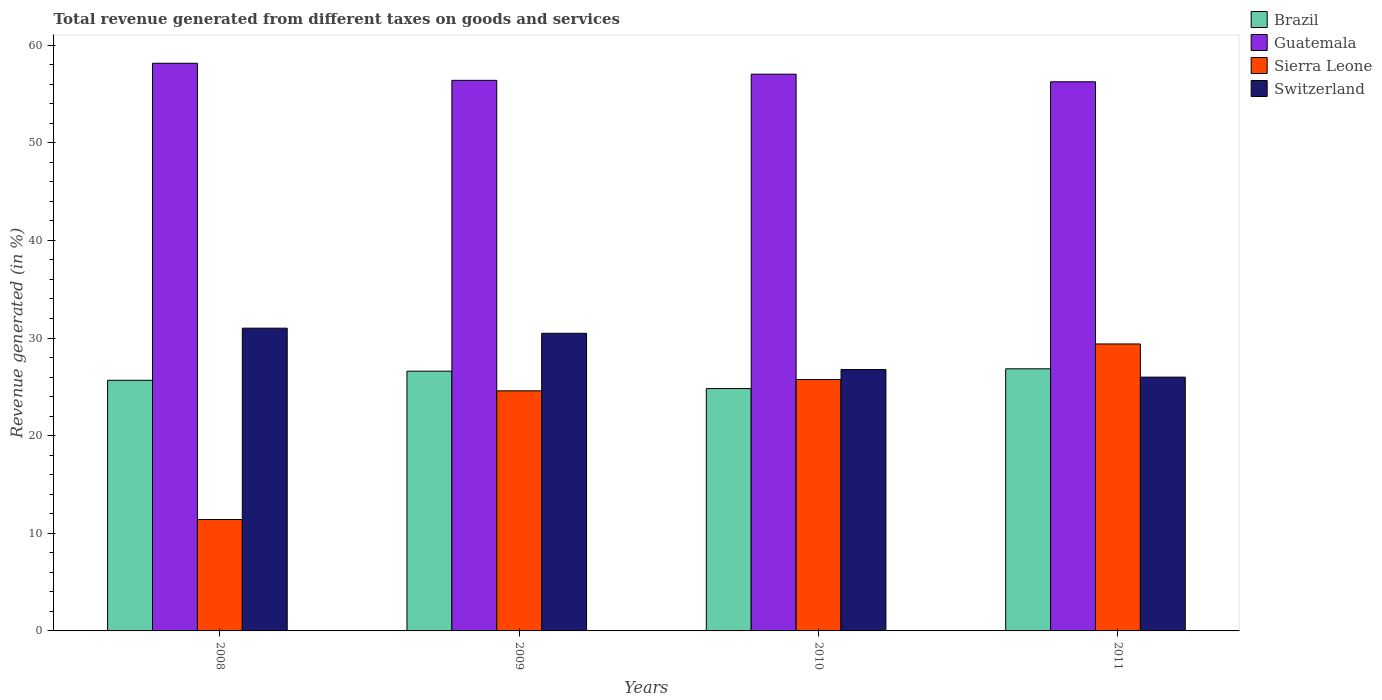How many groups of bars are there?
Your answer should be very brief. 4. Are the number of bars per tick equal to the number of legend labels?
Ensure brevity in your answer.  Yes. Are the number of bars on each tick of the X-axis equal?
Your answer should be very brief. Yes. How many bars are there on the 1st tick from the left?
Give a very brief answer. 4. How many bars are there on the 2nd tick from the right?
Make the answer very short. 4. What is the total revenue generated in Switzerland in 2010?
Provide a short and direct response. 26.77. Across all years, what is the maximum total revenue generated in Sierra Leone?
Keep it short and to the point. 29.39. Across all years, what is the minimum total revenue generated in Switzerland?
Your answer should be compact. 25.99. In which year was the total revenue generated in Brazil maximum?
Your answer should be compact. 2011. What is the total total revenue generated in Switzerland in the graph?
Provide a short and direct response. 114.25. What is the difference between the total revenue generated in Brazil in 2009 and that in 2010?
Offer a very short reply. 1.78. What is the difference between the total revenue generated in Switzerland in 2011 and the total revenue generated in Guatemala in 2010?
Your answer should be compact. -31.03. What is the average total revenue generated in Brazil per year?
Your response must be concise. 25.99. In the year 2008, what is the difference between the total revenue generated in Sierra Leone and total revenue generated in Switzerland?
Your answer should be very brief. -19.6. What is the ratio of the total revenue generated in Brazil in 2008 to that in 2010?
Your response must be concise. 1.03. Is the total revenue generated in Switzerland in 2008 less than that in 2009?
Provide a succinct answer. No. What is the difference between the highest and the second highest total revenue generated in Guatemala?
Provide a short and direct response. 1.12. What is the difference between the highest and the lowest total revenue generated in Sierra Leone?
Your answer should be very brief. 17.98. In how many years, is the total revenue generated in Sierra Leone greater than the average total revenue generated in Sierra Leone taken over all years?
Your response must be concise. 3. Is the sum of the total revenue generated in Sierra Leone in 2009 and 2011 greater than the maximum total revenue generated in Guatemala across all years?
Make the answer very short. No. Is it the case that in every year, the sum of the total revenue generated in Brazil and total revenue generated in Sierra Leone is greater than the sum of total revenue generated in Switzerland and total revenue generated in Guatemala?
Provide a short and direct response. No. What does the 3rd bar from the left in 2011 represents?
Provide a short and direct response. Sierra Leone. What does the 1st bar from the right in 2009 represents?
Offer a terse response. Switzerland. Are the values on the major ticks of Y-axis written in scientific E-notation?
Make the answer very short. No. How many legend labels are there?
Give a very brief answer. 4. What is the title of the graph?
Your response must be concise. Total revenue generated from different taxes on goods and services. What is the label or title of the Y-axis?
Your answer should be very brief. Revenue generated (in %). What is the Revenue generated (in %) of Brazil in 2008?
Offer a very short reply. 25.67. What is the Revenue generated (in %) in Guatemala in 2008?
Your answer should be compact. 58.14. What is the Revenue generated (in %) of Sierra Leone in 2008?
Provide a succinct answer. 11.41. What is the Revenue generated (in %) in Switzerland in 2008?
Provide a succinct answer. 31.01. What is the Revenue generated (in %) of Brazil in 2009?
Your answer should be compact. 26.61. What is the Revenue generated (in %) of Guatemala in 2009?
Offer a terse response. 56.39. What is the Revenue generated (in %) of Sierra Leone in 2009?
Your response must be concise. 24.59. What is the Revenue generated (in %) of Switzerland in 2009?
Your response must be concise. 30.48. What is the Revenue generated (in %) in Brazil in 2010?
Your answer should be compact. 24.82. What is the Revenue generated (in %) in Guatemala in 2010?
Give a very brief answer. 57.02. What is the Revenue generated (in %) of Sierra Leone in 2010?
Give a very brief answer. 25.75. What is the Revenue generated (in %) of Switzerland in 2010?
Provide a short and direct response. 26.77. What is the Revenue generated (in %) of Brazil in 2011?
Your answer should be very brief. 26.85. What is the Revenue generated (in %) of Guatemala in 2011?
Your answer should be compact. 56.25. What is the Revenue generated (in %) of Sierra Leone in 2011?
Ensure brevity in your answer.  29.39. What is the Revenue generated (in %) of Switzerland in 2011?
Your answer should be compact. 25.99. Across all years, what is the maximum Revenue generated (in %) of Brazil?
Provide a succinct answer. 26.85. Across all years, what is the maximum Revenue generated (in %) of Guatemala?
Provide a succinct answer. 58.14. Across all years, what is the maximum Revenue generated (in %) of Sierra Leone?
Keep it short and to the point. 29.39. Across all years, what is the maximum Revenue generated (in %) in Switzerland?
Your answer should be compact. 31.01. Across all years, what is the minimum Revenue generated (in %) in Brazil?
Your response must be concise. 24.82. Across all years, what is the minimum Revenue generated (in %) of Guatemala?
Make the answer very short. 56.25. Across all years, what is the minimum Revenue generated (in %) of Sierra Leone?
Offer a very short reply. 11.41. Across all years, what is the minimum Revenue generated (in %) of Switzerland?
Your answer should be compact. 25.99. What is the total Revenue generated (in %) in Brazil in the graph?
Offer a very short reply. 103.94. What is the total Revenue generated (in %) in Guatemala in the graph?
Your answer should be very brief. 227.8. What is the total Revenue generated (in %) of Sierra Leone in the graph?
Provide a short and direct response. 91.14. What is the total Revenue generated (in %) in Switzerland in the graph?
Offer a terse response. 114.25. What is the difference between the Revenue generated (in %) in Brazil in 2008 and that in 2009?
Make the answer very short. -0.93. What is the difference between the Revenue generated (in %) in Guatemala in 2008 and that in 2009?
Provide a short and direct response. 1.75. What is the difference between the Revenue generated (in %) in Sierra Leone in 2008 and that in 2009?
Make the answer very short. -13.18. What is the difference between the Revenue generated (in %) in Switzerland in 2008 and that in 2009?
Ensure brevity in your answer.  0.53. What is the difference between the Revenue generated (in %) in Brazil in 2008 and that in 2010?
Keep it short and to the point. 0.85. What is the difference between the Revenue generated (in %) of Guatemala in 2008 and that in 2010?
Give a very brief answer. 1.12. What is the difference between the Revenue generated (in %) in Sierra Leone in 2008 and that in 2010?
Your answer should be compact. -14.34. What is the difference between the Revenue generated (in %) of Switzerland in 2008 and that in 2010?
Offer a terse response. 4.24. What is the difference between the Revenue generated (in %) in Brazil in 2008 and that in 2011?
Your answer should be compact. -1.18. What is the difference between the Revenue generated (in %) of Guatemala in 2008 and that in 2011?
Provide a short and direct response. 1.9. What is the difference between the Revenue generated (in %) in Sierra Leone in 2008 and that in 2011?
Keep it short and to the point. -17.98. What is the difference between the Revenue generated (in %) of Switzerland in 2008 and that in 2011?
Your response must be concise. 5.01. What is the difference between the Revenue generated (in %) in Brazil in 2009 and that in 2010?
Your response must be concise. 1.78. What is the difference between the Revenue generated (in %) in Guatemala in 2009 and that in 2010?
Keep it short and to the point. -0.63. What is the difference between the Revenue generated (in %) of Sierra Leone in 2009 and that in 2010?
Provide a short and direct response. -1.16. What is the difference between the Revenue generated (in %) in Switzerland in 2009 and that in 2010?
Your response must be concise. 3.71. What is the difference between the Revenue generated (in %) of Brazil in 2009 and that in 2011?
Provide a short and direct response. -0.24. What is the difference between the Revenue generated (in %) in Guatemala in 2009 and that in 2011?
Your answer should be compact. 0.15. What is the difference between the Revenue generated (in %) in Sierra Leone in 2009 and that in 2011?
Offer a terse response. -4.8. What is the difference between the Revenue generated (in %) in Switzerland in 2009 and that in 2011?
Give a very brief answer. 4.49. What is the difference between the Revenue generated (in %) of Brazil in 2010 and that in 2011?
Give a very brief answer. -2.03. What is the difference between the Revenue generated (in %) in Guatemala in 2010 and that in 2011?
Your response must be concise. 0.78. What is the difference between the Revenue generated (in %) in Sierra Leone in 2010 and that in 2011?
Your answer should be very brief. -3.64. What is the difference between the Revenue generated (in %) of Switzerland in 2010 and that in 2011?
Your response must be concise. 0.77. What is the difference between the Revenue generated (in %) in Brazil in 2008 and the Revenue generated (in %) in Guatemala in 2009?
Offer a terse response. -30.72. What is the difference between the Revenue generated (in %) of Brazil in 2008 and the Revenue generated (in %) of Sierra Leone in 2009?
Provide a short and direct response. 1.08. What is the difference between the Revenue generated (in %) in Brazil in 2008 and the Revenue generated (in %) in Switzerland in 2009?
Provide a short and direct response. -4.81. What is the difference between the Revenue generated (in %) in Guatemala in 2008 and the Revenue generated (in %) in Sierra Leone in 2009?
Your answer should be very brief. 33.55. What is the difference between the Revenue generated (in %) in Guatemala in 2008 and the Revenue generated (in %) in Switzerland in 2009?
Provide a short and direct response. 27.66. What is the difference between the Revenue generated (in %) of Sierra Leone in 2008 and the Revenue generated (in %) of Switzerland in 2009?
Provide a short and direct response. -19.07. What is the difference between the Revenue generated (in %) in Brazil in 2008 and the Revenue generated (in %) in Guatemala in 2010?
Provide a short and direct response. -31.35. What is the difference between the Revenue generated (in %) in Brazil in 2008 and the Revenue generated (in %) in Sierra Leone in 2010?
Your answer should be very brief. -0.08. What is the difference between the Revenue generated (in %) of Brazil in 2008 and the Revenue generated (in %) of Switzerland in 2010?
Provide a short and direct response. -1.1. What is the difference between the Revenue generated (in %) in Guatemala in 2008 and the Revenue generated (in %) in Sierra Leone in 2010?
Give a very brief answer. 32.39. What is the difference between the Revenue generated (in %) in Guatemala in 2008 and the Revenue generated (in %) in Switzerland in 2010?
Provide a succinct answer. 31.37. What is the difference between the Revenue generated (in %) of Sierra Leone in 2008 and the Revenue generated (in %) of Switzerland in 2010?
Provide a short and direct response. -15.36. What is the difference between the Revenue generated (in %) in Brazil in 2008 and the Revenue generated (in %) in Guatemala in 2011?
Your response must be concise. -30.57. What is the difference between the Revenue generated (in %) of Brazil in 2008 and the Revenue generated (in %) of Sierra Leone in 2011?
Offer a terse response. -3.72. What is the difference between the Revenue generated (in %) in Brazil in 2008 and the Revenue generated (in %) in Switzerland in 2011?
Your answer should be compact. -0.32. What is the difference between the Revenue generated (in %) in Guatemala in 2008 and the Revenue generated (in %) in Sierra Leone in 2011?
Offer a very short reply. 28.75. What is the difference between the Revenue generated (in %) of Guatemala in 2008 and the Revenue generated (in %) of Switzerland in 2011?
Your answer should be very brief. 32.15. What is the difference between the Revenue generated (in %) in Sierra Leone in 2008 and the Revenue generated (in %) in Switzerland in 2011?
Keep it short and to the point. -14.58. What is the difference between the Revenue generated (in %) in Brazil in 2009 and the Revenue generated (in %) in Guatemala in 2010?
Provide a short and direct response. -30.42. What is the difference between the Revenue generated (in %) in Brazil in 2009 and the Revenue generated (in %) in Sierra Leone in 2010?
Provide a succinct answer. 0.86. What is the difference between the Revenue generated (in %) in Brazil in 2009 and the Revenue generated (in %) in Switzerland in 2010?
Ensure brevity in your answer.  -0.16. What is the difference between the Revenue generated (in %) in Guatemala in 2009 and the Revenue generated (in %) in Sierra Leone in 2010?
Offer a very short reply. 30.64. What is the difference between the Revenue generated (in %) in Guatemala in 2009 and the Revenue generated (in %) in Switzerland in 2010?
Your answer should be very brief. 29.62. What is the difference between the Revenue generated (in %) in Sierra Leone in 2009 and the Revenue generated (in %) in Switzerland in 2010?
Your answer should be compact. -2.18. What is the difference between the Revenue generated (in %) in Brazil in 2009 and the Revenue generated (in %) in Guatemala in 2011?
Offer a very short reply. -29.64. What is the difference between the Revenue generated (in %) of Brazil in 2009 and the Revenue generated (in %) of Sierra Leone in 2011?
Ensure brevity in your answer.  -2.79. What is the difference between the Revenue generated (in %) in Brazil in 2009 and the Revenue generated (in %) in Switzerland in 2011?
Provide a succinct answer. 0.61. What is the difference between the Revenue generated (in %) in Guatemala in 2009 and the Revenue generated (in %) in Sierra Leone in 2011?
Your answer should be very brief. 27. What is the difference between the Revenue generated (in %) in Guatemala in 2009 and the Revenue generated (in %) in Switzerland in 2011?
Ensure brevity in your answer.  30.4. What is the difference between the Revenue generated (in %) of Sierra Leone in 2009 and the Revenue generated (in %) of Switzerland in 2011?
Give a very brief answer. -1.4. What is the difference between the Revenue generated (in %) of Brazil in 2010 and the Revenue generated (in %) of Guatemala in 2011?
Offer a terse response. -31.42. What is the difference between the Revenue generated (in %) in Brazil in 2010 and the Revenue generated (in %) in Sierra Leone in 2011?
Your answer should be very brief. -4.57. What is the difference between the Revenue generated (in %) of Brazil in 2010 and the Revenue generated (in %) of Switzerland in 2011?
Your answer should be very brief. -1.17. What is the difference between the Revenue generated (in %) of Guatemala in 2010 and the Revenue generated (in %) of Sierra Leone in 2011?
Offer a very short reply. 27.63. What is the difference between the Revenue generated (in %) in Guatemala in 2010 and the Revenue generated (in %) in Switzerland in 2011?
Give a very brief answer. 31.03. What is the difference between the Revenue generated (in %) in Sierra Leone in 2010 and the Revenue generated (in %) in Switzerland in 2011?
Ensure brevity in your answer.  -0.24. What is the average Revenue generated (in %) of Brazil per year?
Your answer should be compact. 25.99. What is the average Revenue generated (in %) in Guatemala per year?
Provide a succinct answer. 56.95. What is the average Revenue generated (in %) of Sierra Leone per year?
Give a very brief answer. 22.79. What is the average Revenue generated (in %) of Switzerland per year?
Ensure brevity in your answer.  28.56. In the year 2008, what is the difference between the Revenue generated (in %) of Brazil and Revenue generated (in %) of Guatemala?
Your answer should be compact. -32.47. In the year 2008, what is the difference between the Revenue generated (in %) in Brazil and Revenue generated (in %) in Sierra Leone?
Ensure brevity in your answer.  14.26. In the year 2008, what is the difference between the Revenue generated (in %) of Brazil and Revenue generated (in %) of Switzerland?
Offer a very short reply. -5.34. In the year 2008, what is the difference between the Revenue generated (in %) in Guatemala and Revenue generated (in %) in Sierra Leone?
Ensure brevity in your answer.  46.73. In the year 2008, what is the difference between the Revenue generated (in %) of Guatemala and Revenue generated (in %) of Switzerland?
Make the answer very short. 27.13. In the year 2008, what is the difference between the Revenue generated (in %) of Sierra Leone and Revenue generated (in %) of Switzerland?
Provide a short and direct response. -19.6. In the year 2009, what is the difference between the Revenue generated (in %) of Brazil and Revenue generated (in %) of Guatemala?
Your answer should be compact. -29.79. In the year 2009, what is the difference between the Revenue generated (in %) in Brazil and Revenue generated (in %) in Sierra Leone?
Provide a short and direct response. 2.01. In the year 2009, what is the difference between the Revenue generated (in %) in Brazil and Revenue generated (in %) in Switzerland?
Offer a very short reply. -3.88. In the year 2009, what is the difference between the Revenue generated (in %) of Guatemala and Revenue generated (in %) of Sierra Leone?
Your answer should be very brief. 31.8. In the year 2009, what is the difference between the Revenue generated (in %) in Guatemala and Revenue generated (in %) in Switzerland?
Your answer should be very brief. 25.91. In the year 2009, what is the difference between the Revenue generated (in %) in Sierra Leone and Revenue generated (in %) in Switzerland?
Provide a short and direct response. -5.89. In the year 2010, what is the difference between the Revenue generated (in %) of Brazil and Revenue generated (in %) of Guatemala?
Make the answer very short. -32.2. In the year 2010, what is the difference between the Revenue generated (in %) in Brazil and Revenue generated (in %) in Sierra Leone?
Provide a short and direct response. -0.93. In the year 2010, what is the difference between the Revenue generated (in %) of Brazil and Revenue generated (in %) of Switzerland?
Your answer should be very brief. -1.95. In the year 2010, what is the difference between the Revenue generated (in %) in Guatemala and Revenue generated (in %) in Sierra Leone?
Provide a succinct answer. 31.27. In the year 2010, what is the difference between the Revenue generated (in %) in Guatemala and Revenue generated (in %) in Switzerland?
Your answer should be very brief. 30.25. In the year 2010, what is the difference between the Revenue generated (in %) of Sierra Leone and Revenue generated (in %) of Switzerland?
Your answer should be very brief. -1.02. In the year 2011, what is the difference between the Revenue generated (in %) in Brazil and Revenue generated (in %) in Guatemala?
Provide a short and direct response. -29.4. In the year 2011, what is the difference between the Revenue generated (in %) of Brazil and Revenue generated (in %) of Sierra Leone?
Offer a very short reply. -2.54. In the year 2011, what is the difference between the Revenue generated (in %) in Brazil and Revenue generated (in %) in Switzerland?
Make the answer very short. 0.85. In the year 2011, what is the difference between the Revenue generated (in %) in Guatemala and Revenue generated (in %) in Sierra Leone?
Your response must be concise. 26.85. In the year 2011, what is the difference between the Revenue generated (in %) of Guatemala and Revenue generated (in %) of Switzerland?
Provide a short and direct response. 30.25. In the year 2011, what is the difference between the Revenue generated (in %) in Sierra Leone and Revenue generated (in %) in Switzerland?
Ensure brevity in your answer.  3.4. What is the ratio of the Revenue generated (in %) in Brazil in 2008 to that in 2009?
Your response must be concise. 0.96. What is the ratio of the Revenue generated (in %) of Guatemala in 2008 to that in 2009?
Ensure brevity in your answer.  1.03. What is the ratio of the Revenue generated (in %) in Sierra Leone in 2008 to that in 2009?
Your answer should be very brief. 0.46. What is the ratio of the Revenue generated (in %) in Switzerland in 2008 to that in 2009?
Your answer should be very brief. 1.02. What is the ratio of the Revenue generated (in %) of Brazil in 2008 to that in 2010?
Ensure brevity in your answer.  1.03. What is the ratio of the Revenue generated (in %) in Guatemala in 2008 to that in 2010?
Keep it short and to the point. 1.02. What is the ratio of the Revenue generated (in %) in Sierra Leone in 2008 to that in 2010?
Your answer should be compact. 0.44. What is the ratio of the Revenue generated (in %) in Switzerland in 2008 to that in 2010?
Provide a succinct answer. 1.16. What is the ratio of the Revenue generated (in %) of Brazil in 2008 to that in 2011?
Make the answer very short. 0.96. What is the ratio of the Revenue generated (in %) of Guatemala in 2008 to that in 2011?
Provide a succinct answer. 1.03. What is the ratio of the Revenue generated (in %) of Sierra Leone in 2008 to that in 2011?
Keep it short and to the point. 0.39. What is the ratio of the Revenue generated (in %) of Switzerland in 2008 to that in 2011?
Keep it short and to the point. 1.19. What is the ratio of the Revenue generated (in %) in Brazil in 2009 to that in 2010?
Make the answer very short. 1.07. What is the ratio of the Revenue generated (in %) in Guatemala in 2009 to that in 2010?
Make the answer very short. 0.99. What is the ratio of the Revenue generated (in %) of Sierra Leone in 2009 to that in 2010?
Give a very brief answer. 0.95. What is the ratio of the Revenue generated (in %) of Switzerland in 2009 to that in 2010?
Provide a short and direct response. 1.14. What is the ratio of the Revenue generated (in %) in Brazil in 2009 to that in 2011?
Your response must be concise. 0.99. What is the ratio of the Revenue generated (in %) in Guatemala in 2009 to that in 2011?
Offer a very short reply. 1. What is the ratio of the Revenue generated (in %) of Sierra Leone in 2009 to that in 2011?
Offer a very short reply. 0.84. What is the ratio of the Revenue generated (in %) of Switzerland in 2009 to that in 2011?
Your response must be concise. 1.17. What is the ratio of the Revenue generated (in %) in Brazil in 2010 to that in 2011?
Offer a very short reply. 0.92. What is the ratio of the Revenue generated (in %) of Guatemala in 2010 to that in 2011?
Your response must be concise. 1.01. What is the ratio of the Revenue generated (in %) in Sierra Leone in 2010 to that in 2011?
Provide a succinct answer. 0.88. What is the ratio of the Revenue generated (in %) in Switzerland in 2010 to that in 2011?
Provide a short and direct response. 1.03. What is the difference between the highest and the second highest Revenue generated (in %) in Brazil?
Your response must be concise. 0.24. What is the difference between the highest and the second highest Revenue generated (in %) of Guatemala?
Your answer should be very brief. 1.12. What is the difference between the highest and the second highest Revenue generated (in %) of Sierra Leone?
Give a very brief answer. 3.64. What is the difference between the highest and the second highest Revenue generated (in %) of Switzerland?
Ensure brevity in your answer.  0.53. What is the difference between the highest and the lowest Revenue generated (in %) in Brazil?
Offer a very short reply. 2.03. What is the difference between the highest and the lowest Revenue generated (in %) of Guatemala?
Offer a very short reply. 1.9. What is the difference between the highest and the lowest Revenue generated (in %) of Sierra Leone?
Provide a short and direct response. 17.98. What is the difference between the highest and the lowest Revenue generated (in %) in Switzerland?
Offer a terse response. 5.01. 